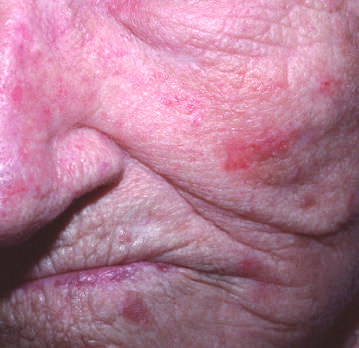what are present on the cheek and nose?
Answer the question using a single word or phrase. Red 